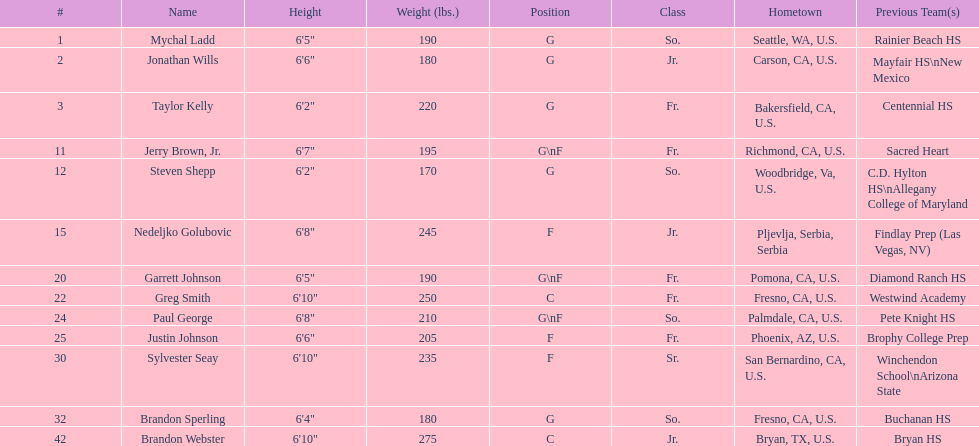How many players, including guards (g) and forwards (f)? 3. 